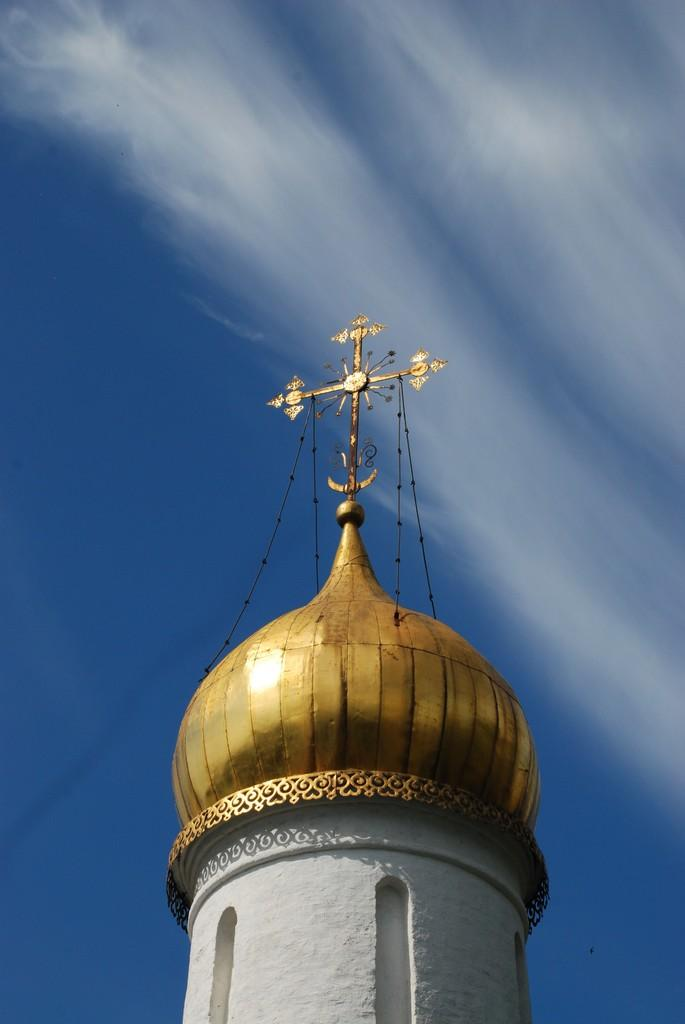What is the main structure in the middle of the image? There is a dome in the middle of the image. What can be seen in the background of the image? The sky is visible in the background of the image. Where is the nest of the zephyr located in the image? There is no nest or zephyr present in the image. What action is taking place in the image? The image does not depict any specific action; it primarily features a dome and the sky. 